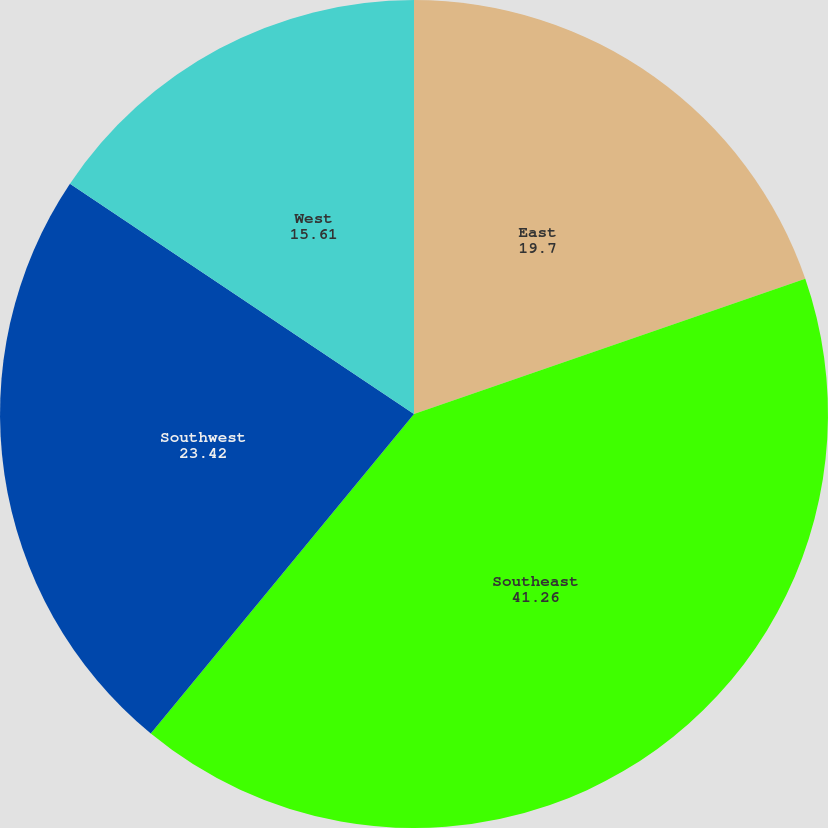<chart> <loc_0><loc_0><loc_500><loc_500><pie_chart><fcel>East<fcel>Southeast<fcel>Southwest<fcel>West<nl><fcel>19.7%<fcel>41.26%<fcel>23.42%<fcel>15.61%<nl></chart> 